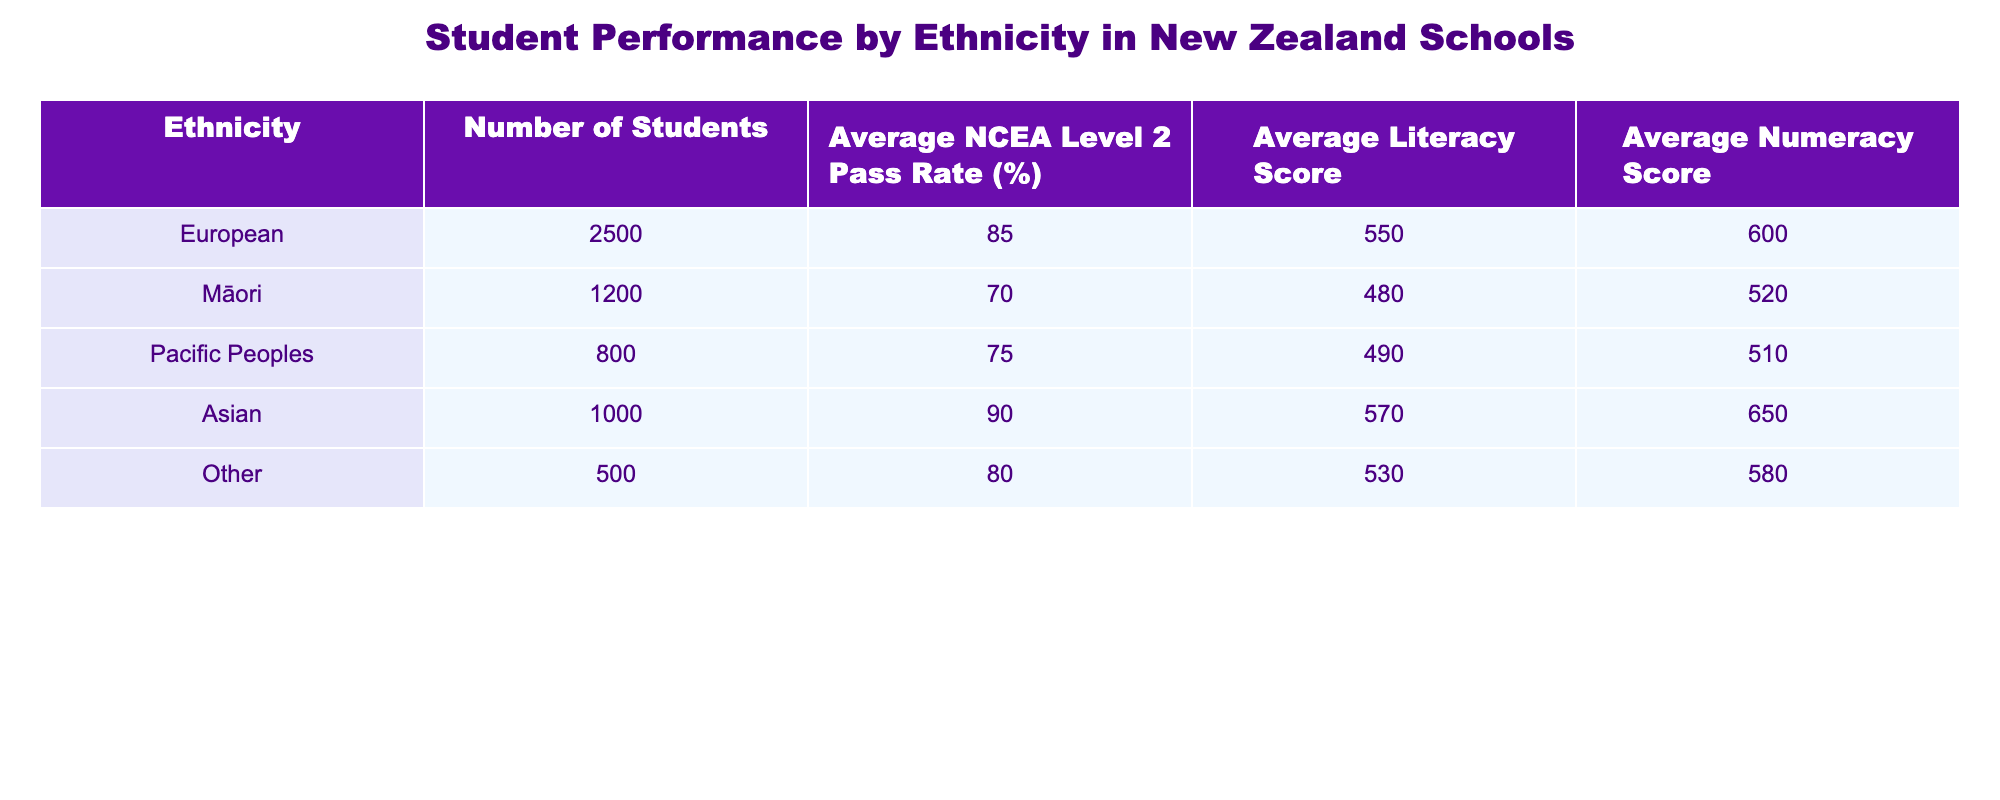What is the average NCEA Level 2 pass rate for Māori students? The table shows that the average NCEA Level 2 pass rate for Māori students is listed under the relevant column. It states 70%.
Answer: 70% How many students are in the Asian ethnicity group? From the table, the number of students in the Asian ethnicity group can be found directly in the relevant column, which is 1000.
Answer: 1000 Which ethnicity has the highest average literacy score? By comparing the average literacy scores in the table, we see that the Asian group has an average of 570, which is higher than all other groups' averages.
Answer: Asian How many more students are there in the European group compared to the Pacific Peoples group? The number of students in the European group is 2500 and in the Pacific Peoples group is 800. The difference is calculated as 2500 - 800 = 1700.
Answer: 1700 Is the average numeracy score for Māori students higher than that for Pacific Peoples students? The table shows that the average numeracy score for Māori students is 520 and for Pacific Peoples students it is 510. Since 520 is greater than 510, the statement is true.
Answer: Yes What is the total number of students across all ethnicities? To find the total, we add the number of students from all groups: 2500 (European) + 1200 (Māori) + 800 (Pacific Peoples) + 1000 (Asian) + 500 (Other) = 5000.
Answer: 5000 What is the difference between the average NCEA Level 2 pass rates of European and Māori students? The average NCEA Level 2 pass rate for European students is 85%, and for Māori, it is 70%. The difference is 85 - 70 = 15.
Answer: 15 Are Asian students performing better on average in numeracy compared to European students? The average numeracy score for Asian students is 650, while for European students it is 600. Since 650 is greater than 600, the statement is true.
Answer: Yes Which ethnicity has the lowest average literacy score, and what is the score? By examining the average literacy scores, the Māori group has the lowest average literacy score at 480.
Answer: Māori, 480 